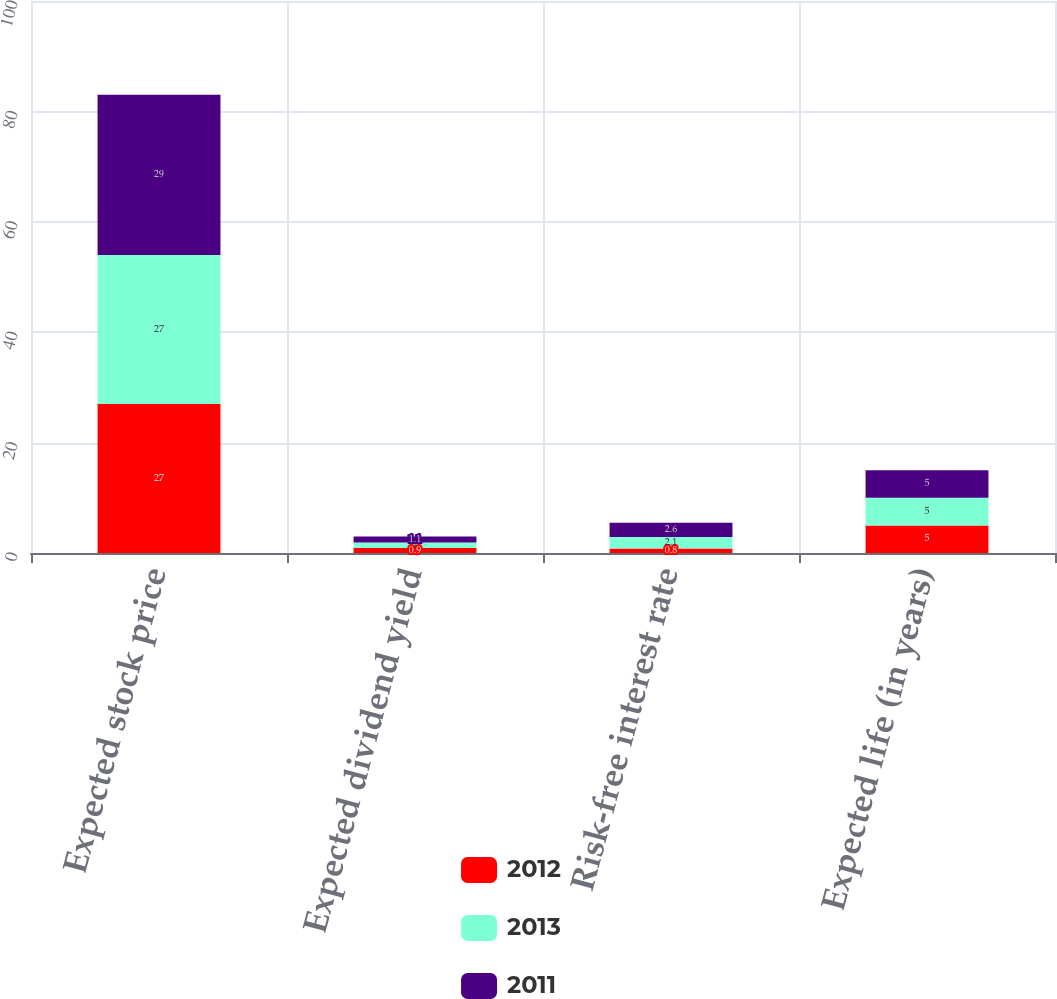Convert chart to OTSL. <chart><loc_0><loc_0><loc_500><loc_500><stacked_bar_chart><ecel><fcel>Expected stock price<fcel>Expected dividend yield<fcel>Risk-free interest rate<fcel>Expected life (in years)<nl><fcel>2012<fcel>27<fcel>0.9<fcel>0.8<fcel>5<nl><fcel>2013<fcel>27<fcel>1<fcel>2.1<fcel>5<nl><fcel>2011<fcel>29<fcel>1.1<fcel>2.6<fcel>5<nl></chart> 